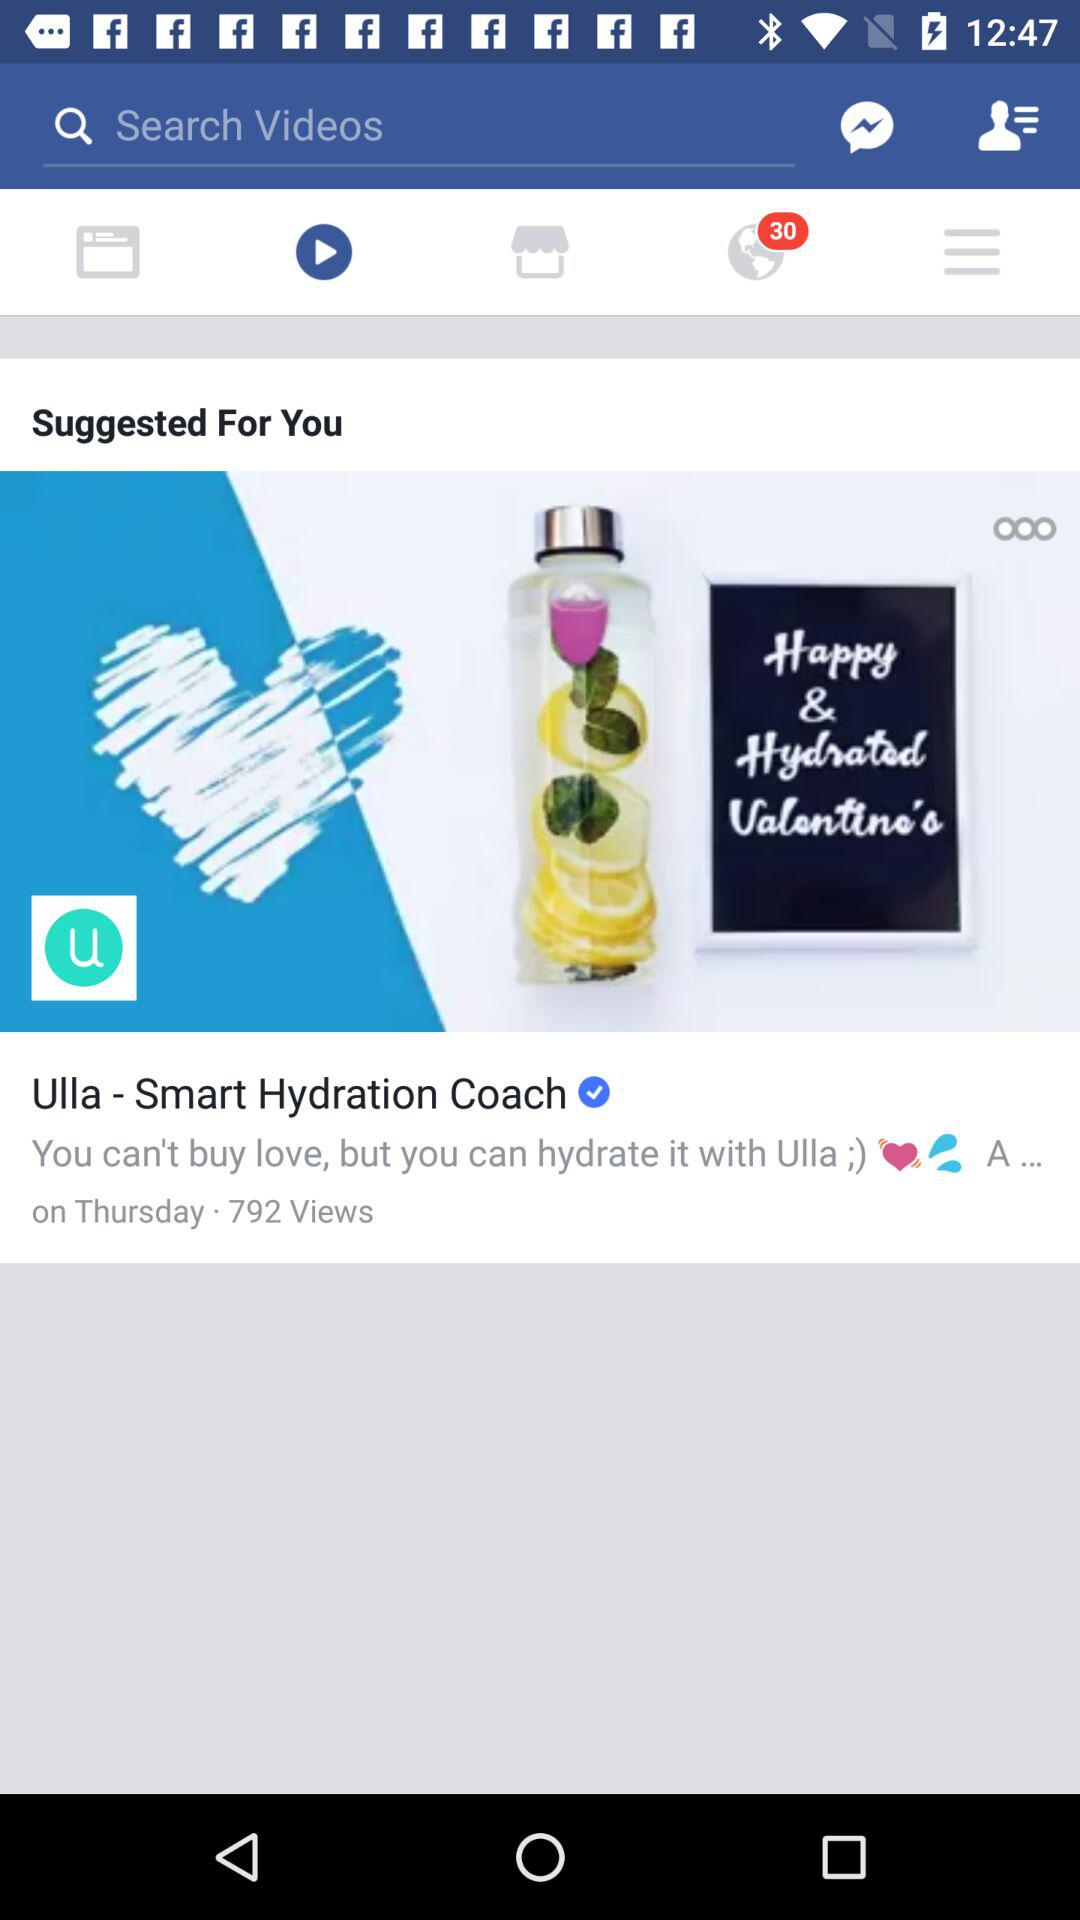What is the day? The day is Thursday. 